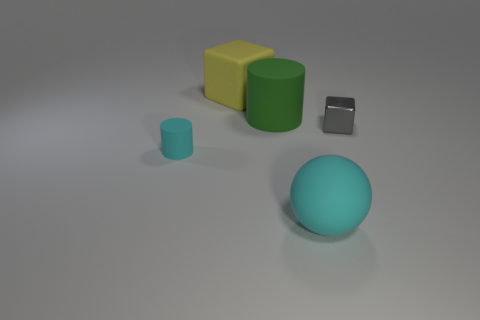Is there any other thing that has the same shape as the big cyan thing?
Your answer should be very brief. No. There is a small shiny thing; is its shape the same as the big yellow matte object that is behind the green cylinder?
Provide a short and direct response. Yes. What is the material of the small block?
Provide a short and direct response. Metal. What is the size of the other object that is the same shape as the gray object?
Your answer should be very brief. Large. What number of other objects are the same material as the gray thing?
Offer a terse response. 0. Are the yellow block and the tiny thing that is on the right side of the green rubber cylinder made of the same material?
Your answer should be very brief. No. Is the number of small gray things that are in front of the large yellow matte object less than the number of rubber objects in front of the gray thing?
Your answer should be very brief. Yes. What color is the big rubber object right of the green thing?
Offer a very short reply. Cyan. What number of other objects are the same color as the tiny rubber cylinder?
Provide a succinct answer. 1. Do the cylinder behind the shiny block and the large cyan matte sphere have the same size?
Your answer should be compact. Yes. 